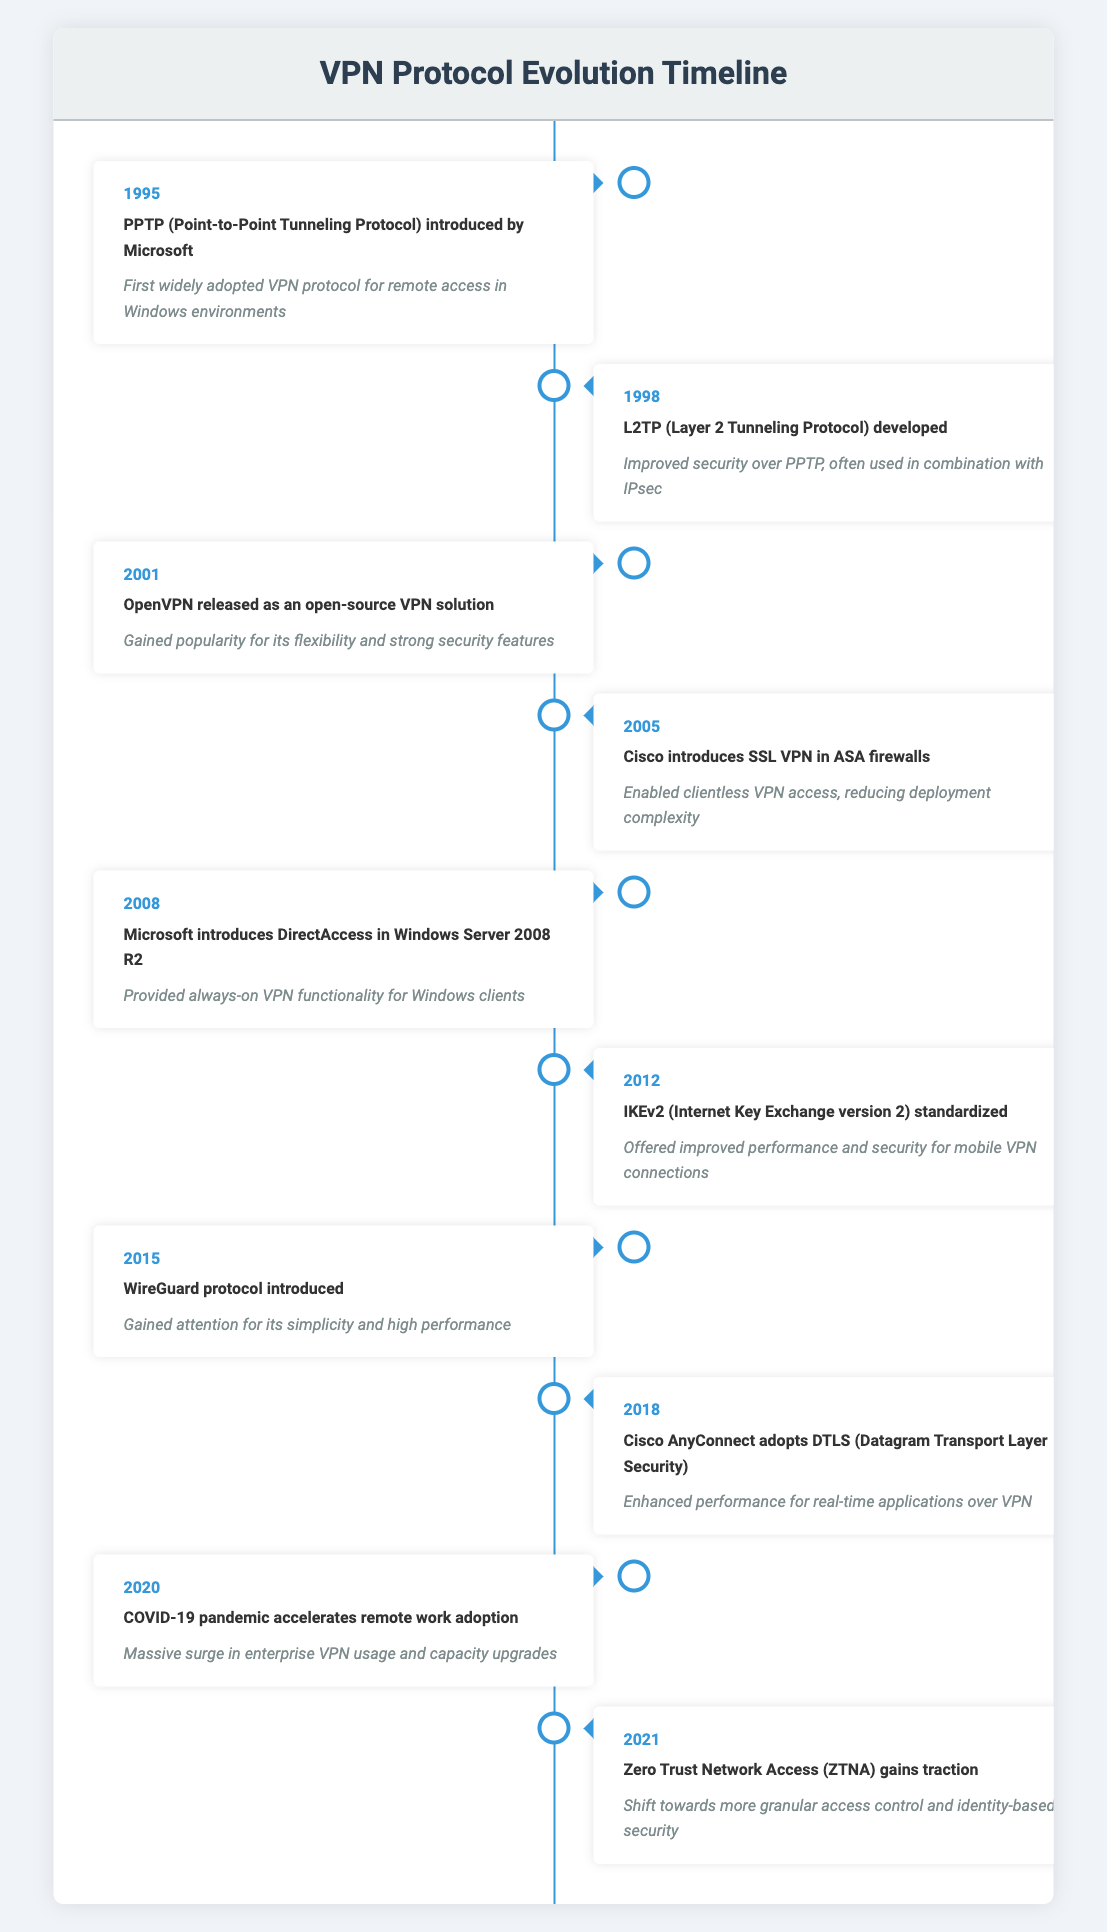What year was PPTP introduced? The table lists the year for each event. Looking at the entry for PPTP, it is introduced in the year 1995.
Answer: 1995 Which VPN protocol was developed in 1998? The table has an event from 1998 that states L2TP (Layer 2 Tunneling Protocol) was developed.
Answer: L2TP What is the impact of OpenVPN released in 2001? According to the table, the impact of OpenVPN released in 2001 is that it gained popularity for its flexibility and strong security features.
Answer: Gained popularity for its flexibility and strong security features What was the main contribution of Cisco introducing SSL VPN in 2005? The impact listed for the 2005 entry notes that it enabled clientless VPN access, which reduced deployment complexity.
Answer: Enabled clientless VPN access, reducing deployment complexity How many VPN protocols were introduced before 2010? The protocols introduced before 2010 are PPTP (1995), L2TP (1998), OpenVPN (2001), SSL VPN (2005), and DirectAccess (2008). Counting these gives us a total of 5.
Answer: 5 What combination of protocols is often used to enhance security according to the timeline? The timeline indicates that L2TP, developed in 1998, is often used in combination with IPsec.
Answer: L2TP and IPsec Was WireGuard introduced before or after COVID-19 pandemic in 2020? The timeline shows WireGuard was introduced in 2015, which is before the COVID-19 pandemic in 2020. Therefore, the answer is before.
Answer: Before What can we infer about the trend of VPN protocol introduction over the years from the table? The table shows that there are consistent developments of various VPN protocols over the years, with notable implementations around critical times like 2001 and during the COVID-19 pandemic in 2020, indicating increasing needs for secure remote access.
Answer: Increasing development and need for secure remote access Did ZTNA gain traction before or after 2020? The timeline indicates that Zero Trust Network Access gained traction in 2021, which is after the acceleration of remote work adoption in 2020 due to the pandemic.
Answer: After What impact did the COVID-19 pandemic have on VPN usage? The table specifically notes that the pandemic caused a massive surge in enterprise VPN usage and capacity upgrades.
Answer: Massive surge in enterprise VPN usage and capacity upgrades 